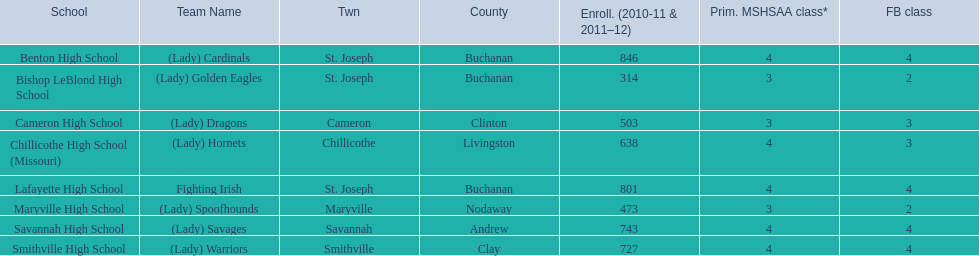How many are enrolled at each school? Benton High School, 846, Bishop LeBlond High School, 314, Cameron High School, 503, Chillicothe High School (Missouri), 638, Lafayette High School, 801, Maryville High School, 473, Savannah High School, 743, Smithville High School, 727. Which school has at only three football classes? Cameron High School, 3, Chillicothe High School (Missouri), 3. Which school has 638 enrolled and 3 football classes? Chillicothe High School (Missouri). 